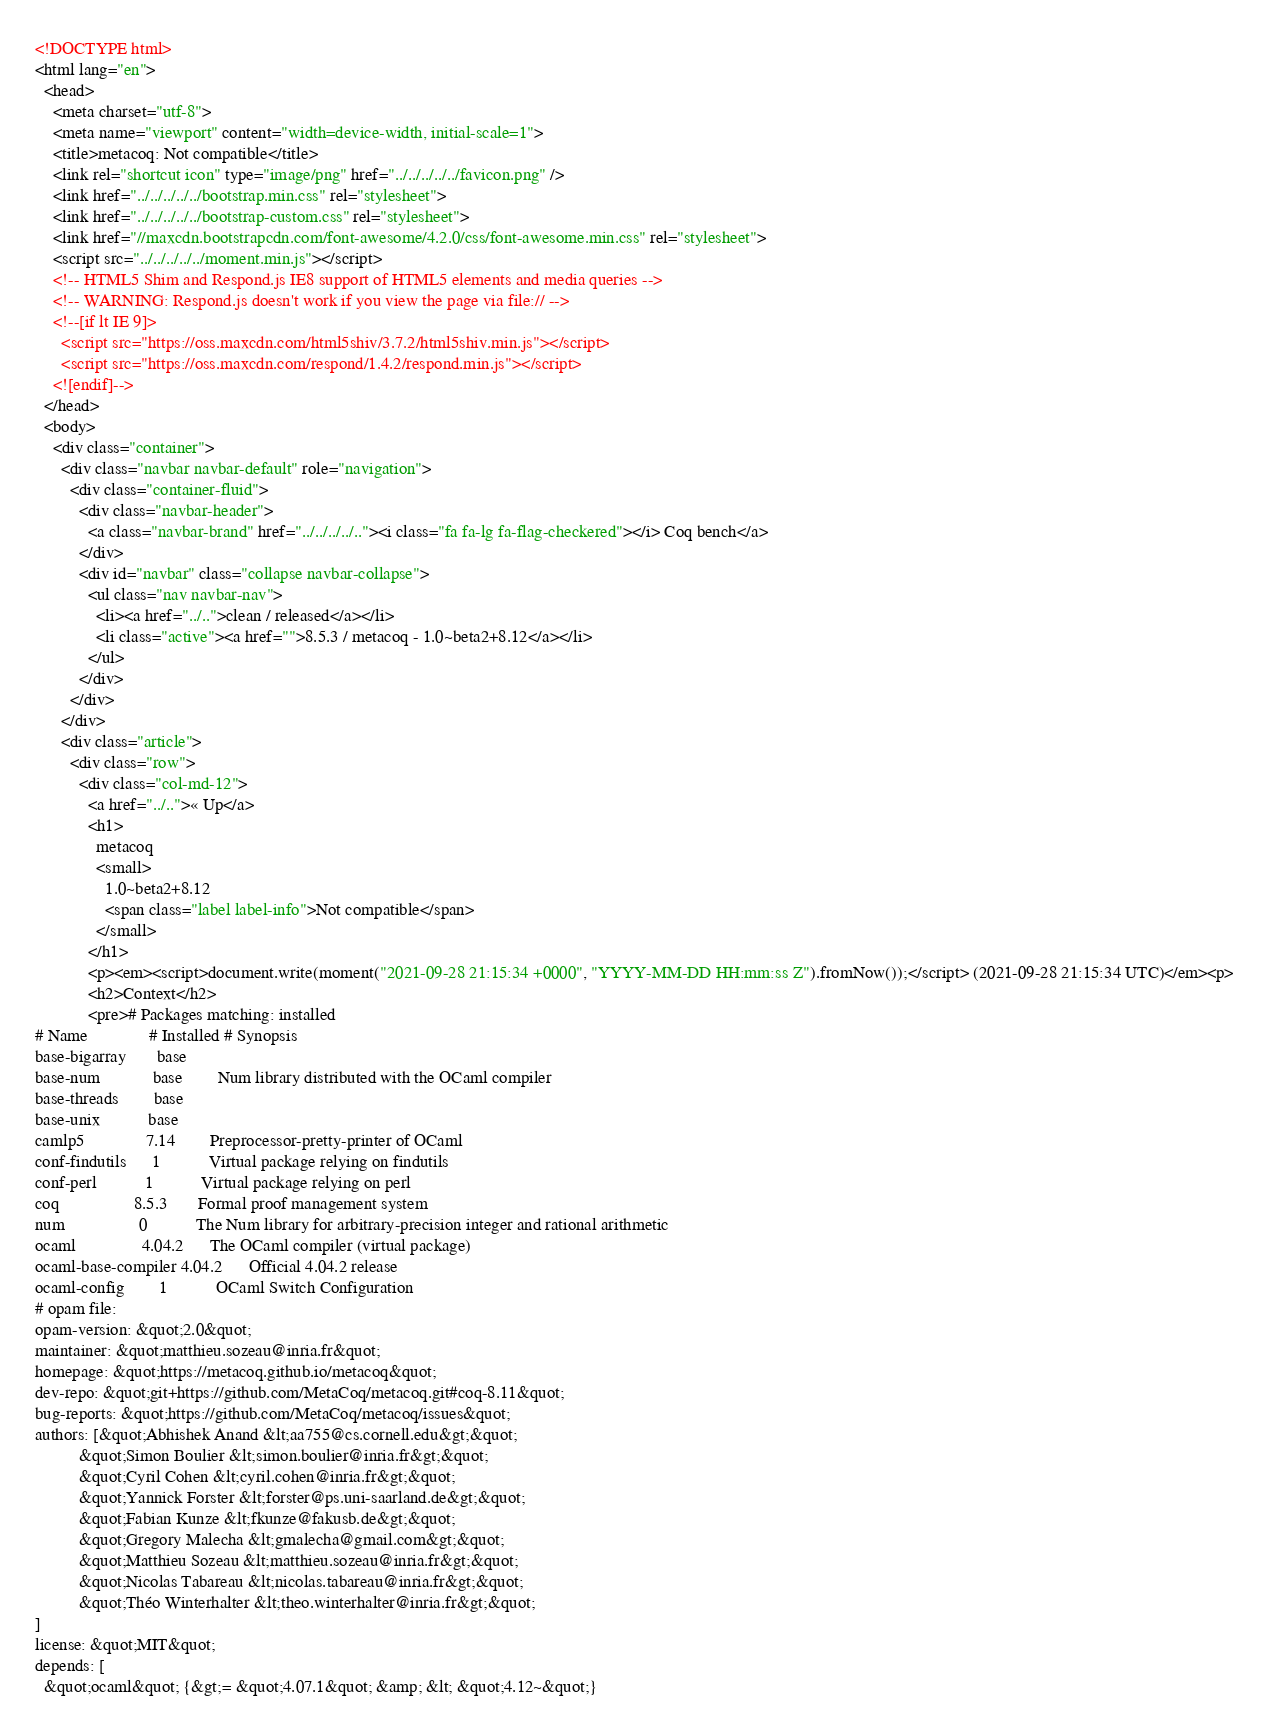Convert code to text. <code><loc_0><loc_0><loc_500><loc_500><_HTML_><!DOCTYPE html>
<html lang="en">
  <head>
    <meta charset="utf-8">
    <meta name="viewport" content="width=device-width, initial-scale=1">
    <title>metacoq: Not compatible</title>
    <link rel="shortcut icon" type="image/png" href="../../../../../favicon.png" />
    <link href="../../../../../bootstrap.min.css" rel="stylesheet">
    <link href="../../../../../bootstrap-custom.css" rel="stylesheet">
    <link href="//maxcdn.bootstrapcdn.com/font-awesome/4.2.0/css/font-awesome.min.css" rel="stylesheet">
    <script src="../../../../../moment.min.js"></script>
    <!-- HTML5 Shim and Respond.js IE8 support of HTML5 elements and media queries -->
    <!-- WARNING: Respond.js doesn't work if you view the page via file:// -->
    <!--[if lt IE 9]>
      <script src="https://oss.maxcdn.com/html5shiv/3.7.2/html5shiv.min.js"></script>
      <script src="https://oss.maxcdn.com/respond/1.4.2/respond.min.js"></script>
    <![endif]-->
  </head>
  <body>
    <div class="container">
      <div class="navbar navbar-default" role="navigation">
        <div class="container-fluid">
          <div class="navbar-header">
            <a class="navbar-brand" href="../../../../.."><i class="fa fa-lg fa-flag-checkered"></i> Coq bench</a>
          </div>
          <div id="navbar" class="collapse navbar-collapse">
            <ul class="nav navbar-nav">
              <li><a href="../..">clean / released</a></li>
              <li class="active"><a href="">8.5.3 / metacoq - 1.0~beta2+8.12</a></li>
            </ul>
          </div>
        </div>
      </div>
      <div class="article">
        <div class="row">
          <div class="col-md-12">
            <a href="../..">« Up</a>
            <h1>
              metacoq
              <small>
                1.0~beta2+8.12
                <span class="label label-info">Not compatible</span>
              </small>
            </h1>
            <p><em><script>document.write(moment("2021-09-28 21:15:34 +0000", "YYYY-MM-DD HH:mm:ss Z").fromNow());</script> (2021-09-28 21:15:34 UTC)</em><p>
            <h2>Context</h2>
            <pre># Packages matching: installed
# Name              # Installed # Synopsis
base-bigarray       base
base-num            base        Num library distributed with the OCaml compiler
base-threads        base
base-unix           base
camlp5              7.14        Preprocessor-pretty-printer of OCaml
conf-findutils      1           Virtual package relying on findutils
conf-perl           1           Virtual package relying on perl
coq                 8.5.3       Formal proof management system
num                 0           The Num library for arbitrary-precision integer and rational arithmetic
ocaml               4.04.2      The OCaml compiler (virtual package)
ocaml-base-compiler 4.04.2      Official 4.04.2 release
ocaml-config        1           OCaml Switch Configuration
# opam file:
opam-version: &quot;2.0&quot;
maintainer: &quot;matthieu.sozeau@inria.fr&quot;
homepage: &quot;https://metacoq.github.io/metacoq&quot;
dev-repo: &quot;git+https://github.com/MetaCoq/metacoq.git#coq-8.11&quot;
bug-reports: &quot;https://github.com/MetaCoq/metacoq/issues&quot;
authors: [&quot;Abhishek Anand &lt;aa755@cs.cornell.edu&gt;&quot;
          &quot;Simon Boulier &lt;simon.boulier@inria.fr&gt;&quot;
          &quot;Cyril Cohen &lt;cyril.cohen@inria.fr&gt;&quot;
          &quot;Yannick Forster &lt;forster@ps.uni-saarland.de&gt;&quot;
          &quot;Fabian Kunze &lt;fkunze@fakusb.de&gt;&quot;
          &quot;Gregory Malecha &lt;gmalecha@gmail.com&gt;&quot;
          &quot;Matthieu Sozeau &lt;matthieu.sozeau@inria.fr&gt;&quot;
          &quot;Nicolas Tabareau &lt;nicolas.tabareau@inria.fr&gt;&quot;
          &quot;Théo Winterhalter &lt;theo.winterhalter@inria.fr&gt;&quot;
]
license: &quot;MIT&quot;
depends: [
  &quot;ocaml&quot; {&gt;= &quot;4.07.1&quot; &amp; &lt; &quot;4.12~&quot;}</code> 